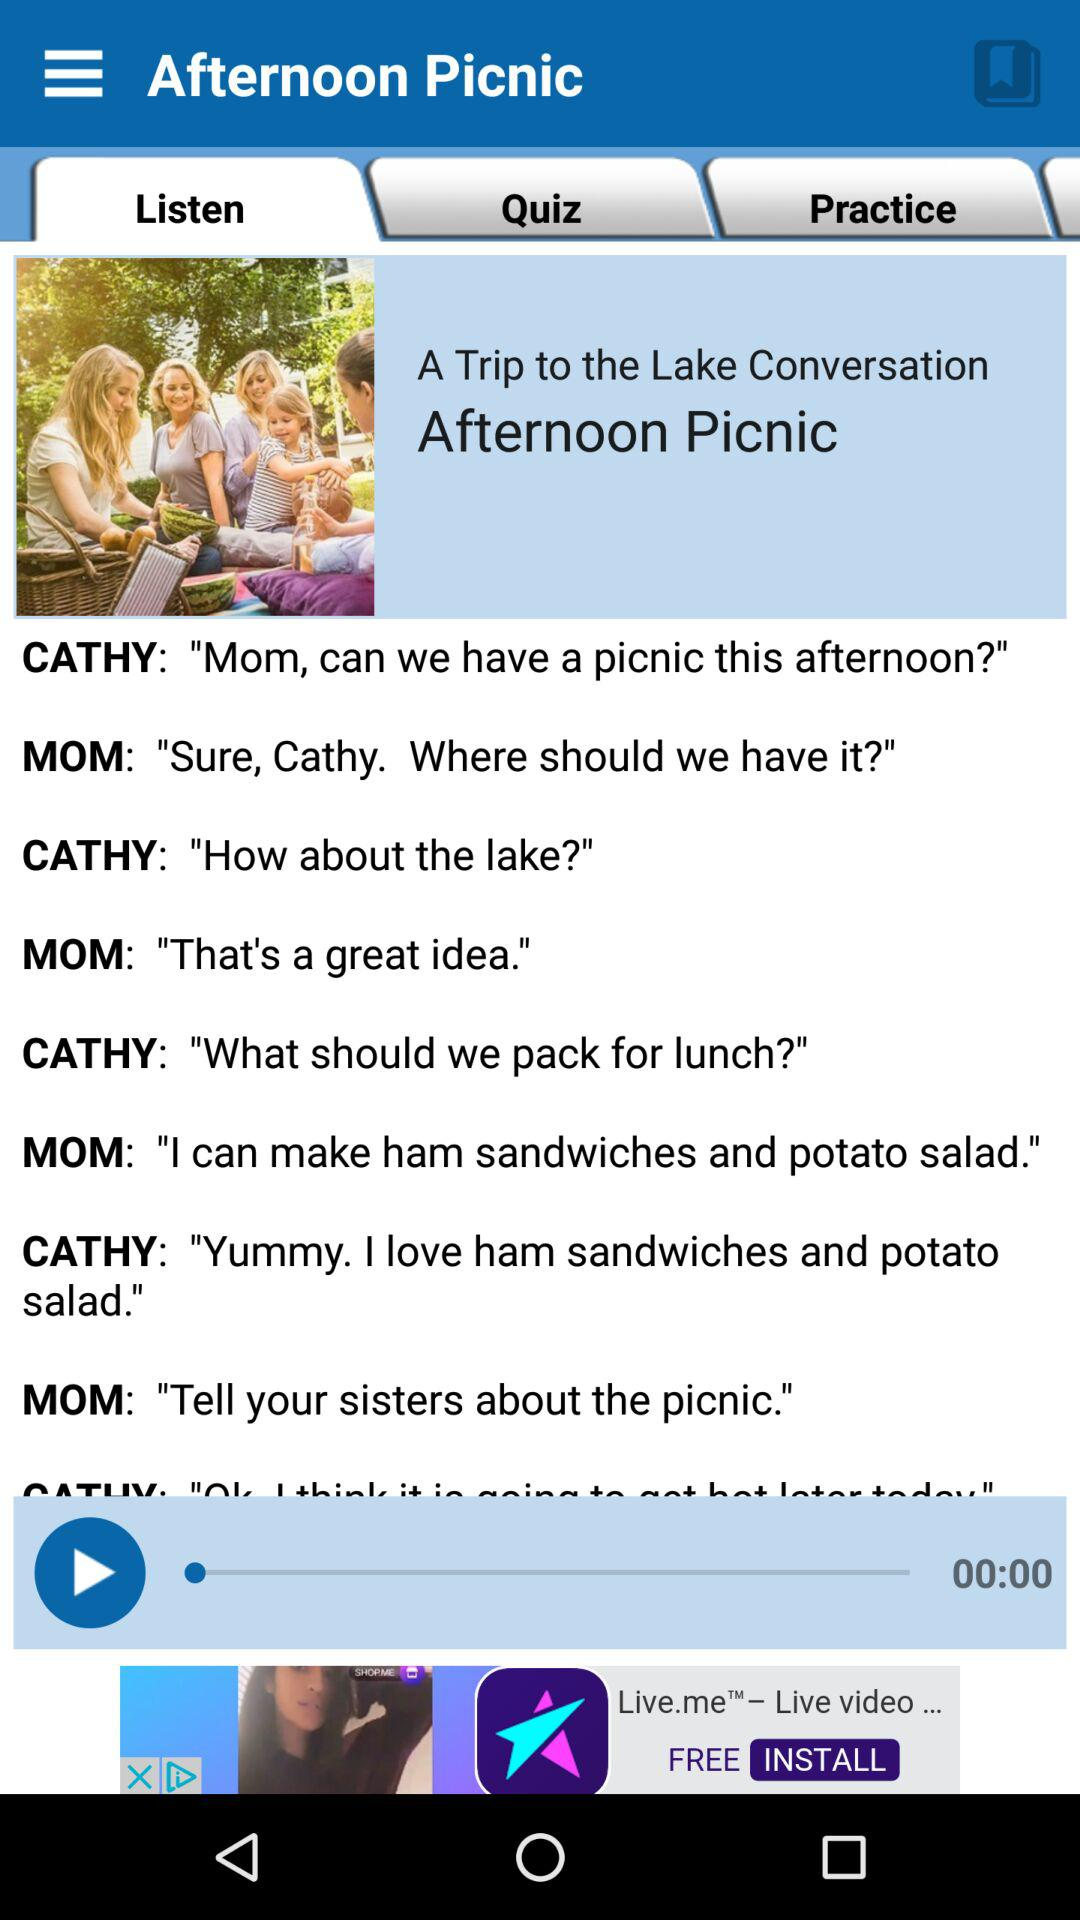What duration shows on screen? The duration is 00:00. 